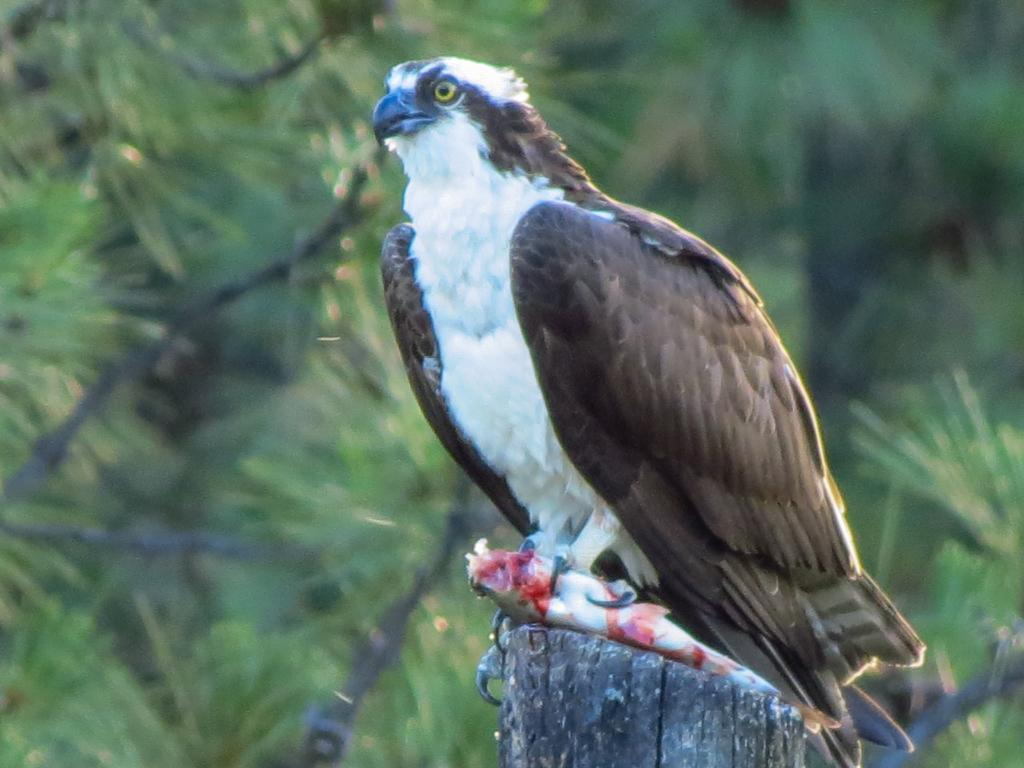What animal is the main subject of the image? There is an eagle in the image. What is the eagle doing in the image? The eagle is sitting on a wooden stick and holding a fish in its claws. What can be seen in the background of the image? There are trees in the background of the image. What type of map is the eagle using to locate its prey in the image? There is no map present in the image, and the eagle is already holding its prey, a fish, in its claws. 